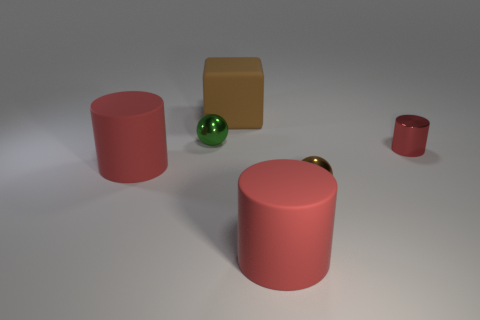There is a tiny thing that is the same color as the rubber block; what is its shape?
Give a very brief answer. Sphere. Is the number of large red rubber things that are behind the tiny brown shiny ball greater than the number of big purple metal balls?
Your answer should be compact. Yes. There is a red cylinder that is made of the same material as the green thing; what size is it?
Make the answer very short. Small. There is a brown rubber thing; are there any large red things on the right side of it?
Offer a terse response. Yes. Does the green thing have the same shape as the red metal object?
Your response must be concise. No. There is a ball that is on the left side of the large red rubber object to the right of the large red cylinder that is behind the brown metallic thing; what is its size?
Offer a terse response. Small. What is the tiny green ball made of?
Ensure brevity in your answer.  Metal. There is a shiny thing that is the same color as the big matte cube; what is its size?
Give a very brief answer. Small. There is a tiny red thing; is its shape the same as the large object that is right of the rubber block?
Your answer should be compact. Yes. What material is the ball that is behind the rubber cylinder that is left of the ball that is behind the small metal cylinder made of?
Your answer should be very brief. Metal. 